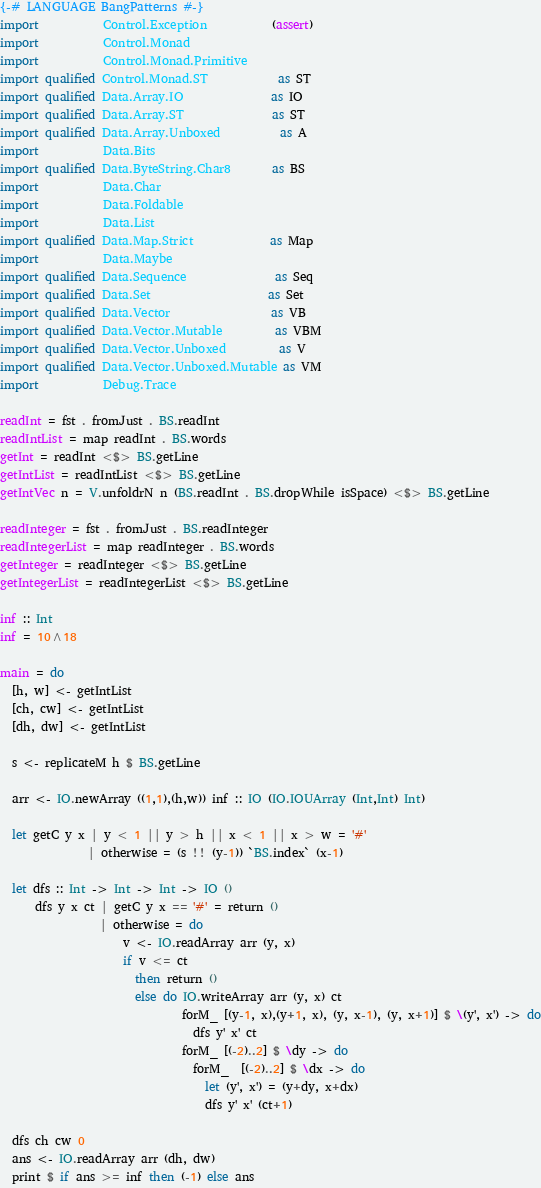<code> <loc_0><loc_0><loc_500><loc_500><_Haskell_>{-# LANGUAGE BangPatterns #-}
import           Control.Exception           (assert)
import           Control.Monad
import           Control.Monad.Primitive
import qualified Control.Monad.ST            as ST
import qualified Data.Array.IO               as IO
import qualified Data.Array.ST               as ST
import qualified Data.Array.Unboxed          as A
import           Data.Bits
import qualified Data.ByteString.Char8       as BS
import           Data.Char
import           Data.Foldable
import           Data.List
import qualified Data.Map.Strict             as Map
import           Data.Maybe
import qualified Data.Sequence               as Seq
import qualified Data.Set                    as Set
import qualified Data.Vector                 as VB
import qualified Data.Vector.Mutable         as VBM
import qualified Data.Vector.Unboxed         as V
import qualified Data.Vector.Unboxed.Mutable as VM
import           Debug.Trace

readInt = fst . fromJust . BS.readInt
readIntList = map readInt . BS.words
getInt = readInt <$> BS.getLine
getIntList = readIntList <$> BS.getLine
getIntVec n = V.unfoldrN n (BS.readInt . BS.dropWhile isSpace) <$> BS.getLine

readInteger = fst . fromJust . BS.readInteger
readIntegerList = map readInteger . BS.words
getInteger = readInteger <$> BS.getLine
getIntegerList = readIntegerList <$> BS.getLine

inf :: Int
inf = 10^18

main = do
  [h, w] <- getIntList
  [ch, cw] <- getIntList
  [dh, dw] <- getIntList

  s <- replicateM h $ BS.getLine

  arr <- IO.newArray ((1,1),(h,w)) inf :: IO (IO.IOUArray (Int,Int) Int)

  let getC y x | y < 1 || y > h || x < 1 || x > w = '#'
               | otherwise = (s !! (y-1)) `BS.index` (x-1)

  let dfs :: Int -> Int -> Int -> IO ()
      dfs y x ct | getC y x == '#' = return ()
                 | otherwise = do
                     v <- IO.readArray arr (y, x)
                     if v <= ct
                       then return ()
                       else do IO.writeArray arr (y, x) ct
                               forM_ [(y-1, x),(y+1, x), (y, x-1), (y, x+1)] $ \(y', x') -> do
                                 dfs y' x' ct
                               forM_ [(-2)..2] $ \dy -> do
                                 forM_  [(-2)..2] $ \dx -> do
                                   let (y', x') = (y+dy, x+dx)
                                   dfs y' x' (ct+1)

  dfs ch cw 0
  ans <- IO.readArray arr (dh, dw)
  print $ if ans >= inf then (-1) else ans
</code> 